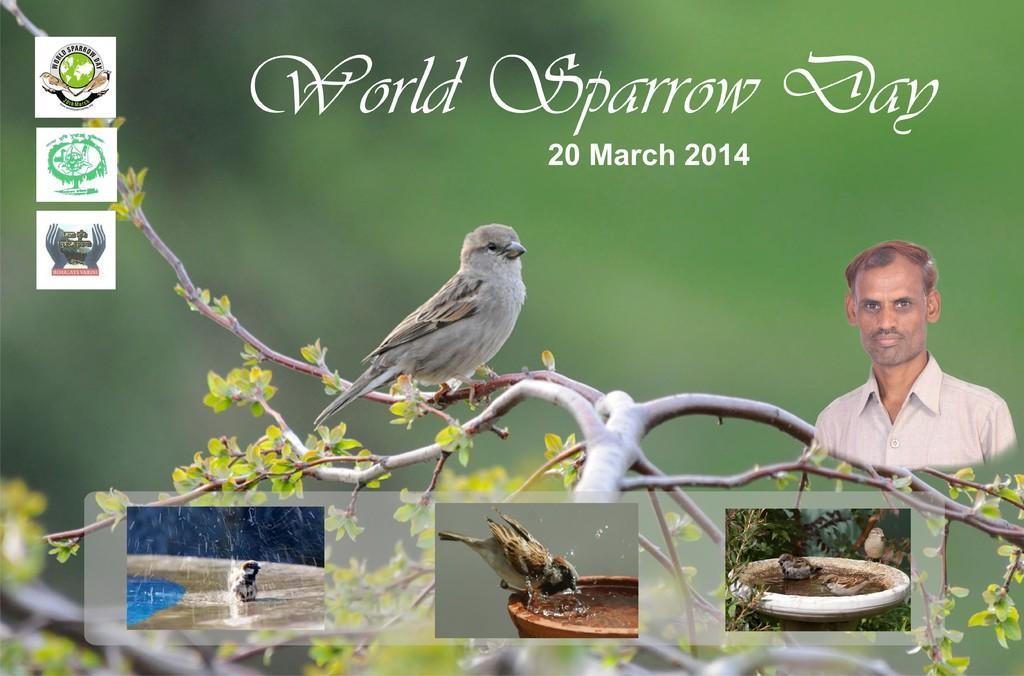Describe this image in one or two sentences. As we can see in the image there is a banner. On banner there is a tree branch, nest, birds and a man on the right side. 